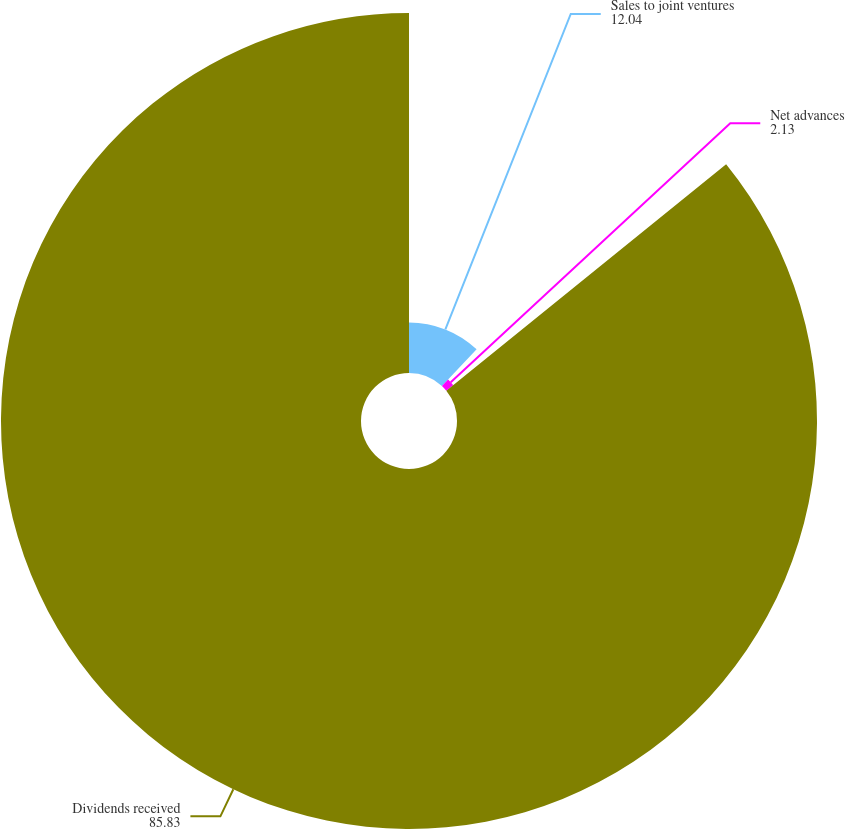<chart> <loc_0><loc_0><loc_500><loc_500><pie_chart><fcel>Sales to joint ventures<fcel>Net advances<fcel>Dividends received<nl><fcel>12.04%<fcel>2.13%<fcel>85.83%<nl></chart> 